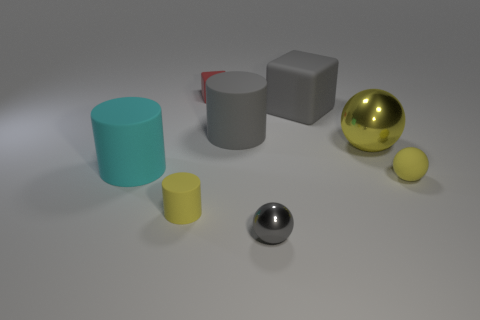Add 1 tiny things. How many objects exist? 9 Subtract all spheres. How many objects are left? 5 Subtract 0 brown cylinders. How many objects are left? 8 Subtract all rubber balls. Subtract all tiny yellow rubber things. How many objects are left? 5 Add 1 yellow metallic objects. How many yellow metallic objects are left? 2 Add 2 big green spheres. How many big green spheres exist? 2 